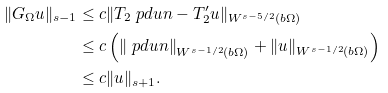Convert formula to latex. <formula><loc_0><loc_0><loc_500><loc_500>\| G _ { \Omega } u \| _ { s - 1 } & \leq c \| T _ { 2 } \ p d { u } { n } - T ^ { \prime } _ { 2 } u \| _ { W ^ { s - 5 / 2 } ( b \Omega ) } \\ & \leq c \left ( \left \| \ p d { u } { n } \right \| _ { W ^ { s - 1 / 2 } ( b \Omega ) } + \| u \| _ { W ^ { s - 1 / 2 } ( b \Omega ) } \right ) \\ & \leq c \| u \| _ { s + 1 } .</formula> 